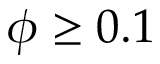<formula> <loc_0><loc_0><loc_500><loc_500>\phi \geq 0 . 1</formula> 